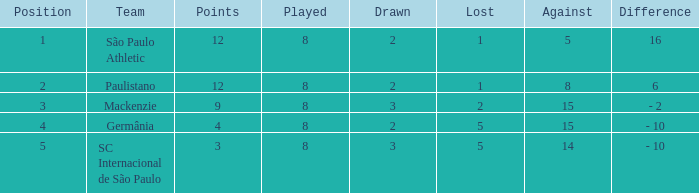What was the status with the overall number less than 1? 0.0. 